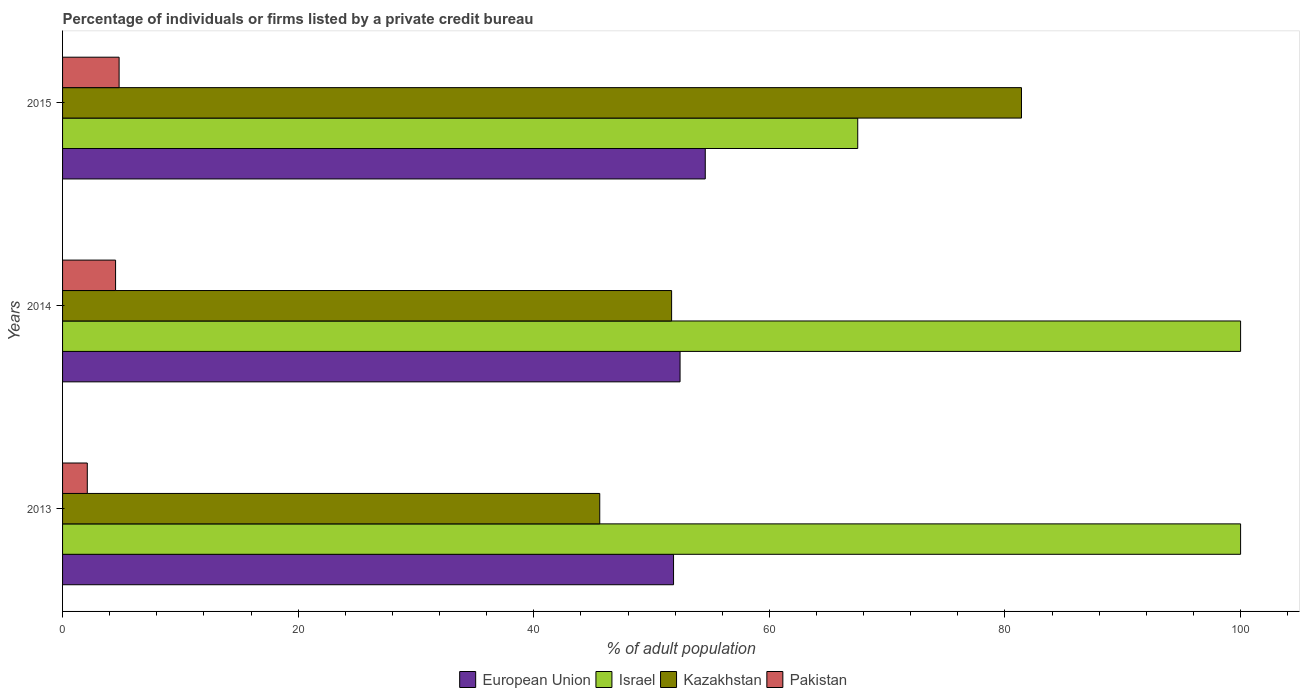How many bars are there on the 3rd tick from the bottom?
Keep it short and to the point. 4. In how many cases, is the number of bars for a given year not equal to the number of legend labels?
Provide a succinct answer. 0. What is the percentage of population listed by a private credit bureau in Israel in 2014?
Offer a terse response. 100. Across all years, what is the maximum percentage of population listed by a private credit bureau in Kazakhstan?
Make the answer very short. 81.4. Across all years, what is the minimum percentage of population listed by a private credit bureau in Israel?
Offer a very short reply. 67.5. What is the total percentage of population listed by a private credit bureau in Kazakhstan in the graph?
Provide a succinct answer. 178.7. What is the difference between the percentage of population listed by a private credit bureau in Kazakhstan in 2013 and that in 2014?
Offer a terse response. -6.1. What is the difference between the percentage of population listed by a private credit bureau in Pakistan in 2014 and the percentage of population listed by a private credit bureau in Israel in 2015?
Provide a short and direct response. -63. What is the average percentage of population listed by a private credit bureau in European Union per year?
Offer a terse response. 52.95. In the year 2013, what is the difference between the percentage of population listed by a private credit bureau in European Union and percentage of population listed by a private credit bureau in Israel?
Provide a succinct answer. -48.14. In how many years, is the percentage of population listed by a private credit bureau in Kazakhstan greater than 36 %?
Provide a short and direct response. 3. What is the ratio of the percentage of population listed by a private credit bureau in Kazakhstan in 2013 to that in 2014?
Your response must be concise. 0.88. Is the percentage of population listed by a private credit bureau in European Union in 2013 less than that in 2014?
Give a very brief answer. Yes. What is the difference between the highest and the second highest percentage of population listed by a private credit bureau in Kazakhstan?
Your response must be concise. 29.7. What is the difference between the highest and the lowest percentage of population listed by a private credit bureau in Kazakhstan?
Keep it short and to the point. 35.8. In how many years, is the percentage of population listed by a private credit bureau in Israel greater than the average percentage of population listed by a private credit bureau in Israel taken over all years?
Offer a very short reply. 2. Is the sum of the percentage of population listed by a private credit bureau in Kazakhstan in 2013 and 2014 greater than the maximum percentage of population listed by a private credit bureau in Pakistan across all years?
Ensure brevity in your answer.  Yes. Is it the case that in every year, the sum of the percentage of population listed by a private credit bureau in Pakistan and percentage of population listed by a private credit bureau in Kazakhstan is greater than the sum of percentage of population listed by a private credit bureau in Israel and percentage of population listed by a private credit bureau in European Union?
Offer a very short reply. No. What does the 4th bar from the top in 2015 represents?
Provide a short and direct response. European Union. What does the 3rd bar from the bottom in 2014 represents?
Offer a terse response. Kazakhstan. How many bars are there?
Offer a terse response. 12. How many years are there in the graph?
Ensure brevity in your answer.  3. What is the difference between two consecutive major ticks on the X-axis?
Your response must be concise. 20. Are the values on the major ticks of X-axis written in scientific E-notation?
Offer a very short reply. No. Does the graph contain any zero values?
Give a very brief answer. No. Does the graph contain grids?
Your answer should be compact. No. How many legend labels are there?
Ensure brevity in your answer.  4. What is the title of the graph?
Ensure brevity in your answer.  Percentage of individuals or firms listed by a private credit bureau. What is the label or title of the X-axis?
Provide a short and direct response. % of adult population. What is the % of adult population of European Union in 2013?
Provide a succinct answer. 51.86. What is the % of adult population of Israel in 2013?
Your answer should be compact. 100. What is the % of adult population in Kazakhstan in 2013?
Give a very brief answer. 45.6. What is the % of adult population in European Union in 2014?
Your answer should be compact. 52.42. What is the % of adult population of Israel in 2014?
Offer a very short reply. 100. What is the % of adult population in Kazakhstan in 2014?
Provide a short and direct response. 51.7. What is the % of adult population in Pakistan in 2014?
Offer a terse response. 4.5. What is the % of adult population in European Union in 2015?
Offer a very short reply. 54.56. What is the % of adult population of Israel in 2015?
Give a very brief answer. 67.5. What is the % of adult population of Kazakhstan in 2015?
Your response must be concise. 81.4. What is the % of adult population of Pakistan in 2015?
Your answer should be very brief. 4.8. Across all years, what is the maximum % of adult population of European Union?
Your answer should be compact. 54.56. Across all years, what is the maximum % of adult population of Kazakhstan?
Make the answer very short. 81.4. Across all years, what is the maximum % of adult population in Pakistan?
Your response must be concise. 4.8. Across all years, what is the minimum % of adult population of European Union?
Ensure brevity in your answer.  51.86. Across all years, what is the minimum % of adult population in Israel?
Ensure brevity in your answer.  67.5. Across all years, what is the minimum % of adult population in Kazakhstan?
Offer a very short reply. 45.6. Across all years, what is the minimum % of adult population of Pakistan?
Offer a terse response. 2.1. What is the total % of adult population of European Union in the graph?
Keep it short and to the point. 158.84. What is the total % of adult population of Israel in the graph?
Keep it short and to the point. 267.5. What is the total % of adult population of Kazakhstan in the graph?
Your response must be concise. 178.7. What is the difference between the % of adult population of European Union in 2013 and that in 2014?
Keep it short and to the point. -0.55. What is the difference between the % of adult population in Israel in 2013 and that in 2014?
Keep it short and to the point. 0. What is the difference between the % of adult population of Kazakhstan in 2013 and that in 2014?
Make the answer very short. -6.1. What is the difference between the % of adult population of Pakistan in 2013 and that in 2014?
Give a very brief answer. -2.4. What is the difference between the % of adult population of European Union in 2013 and that in 2015?
Provide a short and direct response. -2.69. What is the difference between the % of adult population in Israel in 2013 and that in 2015?
Your answer should be compact. 32.5. What is the difference between the % of adult population of Kazakhstan in 2013 and that in 2015?
Make the answer very short. -35.8. What is the difference between the % of adult population in European Union in 2014 and that in 2015?
Offer a very short reply. -2.14. What is the difference between the % of adult population in Israel in 2014 and that in 2015?
Your response must be concise. 32.5. What is the difference between the % of adult population of Kazakhstan in 2014 and that in 2015?
Provide a short and direct response. -29.7. What is the difference between the % of adult population of Pakistan in 2014 and that in 2015?
Offer a very short reply. -0.3. What is the difference between the % of adult population of European Union in 2013 and the % of adult population of Israel in 2014?
Ensure brevity in your answer.  -48.14. What is the difference between the % of adult population of European Union in 2013 and the % of adult population of Kazakhstan in 2014?
Provide a short and direct response. 0.16. What is the difference between the % of adult population in European Union in 2013 and the % of adult population in Pakistan in 2014?
Provide a short and direct response. 47.36. What is the difference between the % of adult population of Israel in 2013 and the % of adult population of Kazakhstan in 2014?
Your answer should be compact. 48.3. What is the difference between the % of adult population of Israel in 2013 and the % of adult population of Pakistan in 2014?
Your response must be concise. 95.5. What is the difference between the % of adult population in Kazakhstan in 2013 and the % of adult population in Pakistan in 2014?
Make the answer very short. 41.1. What is the difference between the % of adult population in European Union in 2013 and the % of adult population in Israel in 2015?
Ensure brevity in your answer.  -15.64. What is the difference between the % of adult population in European Union in 2013 and the % of adult population in Kazakhstan in 2015?
Keep it short and to the point. -29.54. What is the difference between the % of adult population in European Union in 2013 and the % of adult population in Pakistan in 2015?
Your answer should be very brief. 47.06. What is the difference between the % of adult population of Israel in 2013 and the % of adult population of Pakistan in 2015?
Provide a short and direct response. 95.2. What is the difference between the % of adult population of Kazakhstan in 2013 and the % of adult population of Pakistan in 2015?
Provide a short and direct response. 40.8. What is the difference between the % of adult population in European Union in 2014 and the % of adult population in Israel in 2015?
Your response must be concise. -15.08. What is the difference between the % of adult population of European Union in 2014 and the % of adult population of Kazakhstan in 2015?
Give a very brief answer. -28.98. What is the difference between the % of adult population in European Union in 2014 and the % of adult population in Pakistan in 2015?
Your answer should be very brief. 47.62. What is the difference between the % of adult population in Israel in 2014 and the % of adult population in Pakistan in 2015?
Your answer should be very brief. 95.2. What is the difference between the % of adult population of Kazakhstan in 2014 and the % of adult population of Pakistan in 2015?
Provide a succinct answer. 46.9. What is the average % of adult population in European Union per year?
Keep it short and to the point. 52.95. What is the average % of adult population of Israel per year?
Keep it short and to the point. 89.17. What is the average % of adult population in Kazakhstan per year?
Make the answer very short. 59.57. In the year 2013, what is the difference between the % of adult population in European Union and % of adult population in Israel?
Provide a succinct answer. -48.14. In the year 2013, what is the difference between the % of adult population in European Union and % of adult population in Kazakhstan?
Ensure brevity in your answer.  6.26. In the year 2013, what is the difference between the % of adult population in European Union and % of adult population in Pakistan?
Provide a short and direct response. 49.76. In the year 2013, what is the difference between the % of adult population of Israel and % of adult population of Kazakhstan?
Provide a succinct answer. 54.4. In the year 2013, what is the difference between the % of adult population of Israel and % of adult population of Pakistan?
Provide a short and direct response. 97.9. In the year 2013, what is the difference between the % of adult population of Kazakhstan and % of adult population of Pakistan?
Your answer should be very brief. 43.5. In the year 2014, what is the difference between the % of adult population of European Union and % of adult population of Israel?
Offer a terse response. -47.58. In the year 2014, what is the difference between the % of adult population in European Union and % of adult population in Kazakhstan?
Ensure brevity in your answer.  0.72. In the year 2014, what is the difference between the % of adult population in European Union and % of adult population in Pakistan?
Your response must be concise. 47.92. In the year 2014, what is the difference between the % of adult population in Israel and % of adult population in Kazakhstan?
Make the answer very short. 48.3. In the year 2014, what is the difference between the % of adult population of Israel and % of adult population of Pakistan?
Provide a succinct answer. 95.5. In the year 2014, what is the difference between the % of adult population of Kazakhstan and % of adult population of Pakistan?
Your answer should be very brief. 47.2. In the year 2015, what is the difference between the % of adult population in European Union and % of adult population in Israel?
Provide a succinct answer. -12.94. In the year 2015, what is the difference between the % of adult population in European Union and % of adult population in Kazakhstan?
Ensure brevity in your answer.  -26.84. In the year 2015, what is the difference between the % of adult population in European Union and % of adult population in Pakistan?
Offer a very short reply. 49.76. In the year 2015, what is the difference between the % of adult population of Israel and % of adult population of Kazakhstan?
Your response must be concise. -13.9. In the year 2015, what is the difference between the % of adult population in Israel and % of adult population in Pakistan?
Make the answer very short. 62.7. In the year 2015, what is the difference between the % of adult population of Kazakhstan and % of adult population of Pakistan?
Give a very brief answer. 76.6. What is the ratio of the % of adult population in European Union in 2013 to that in 2014?
Your response must be concise. 0.99. What is the ratio of the % of adult population in Kazakhstan in 2013 to that in 2014?
Provide a short and direct response. 0.88. What is the ratio of the % of adult population in Pakistan in 2013 to that in 2014?
Offer a terse response. 0.47. What is the ratio of the % of adult population in European Union in 2013 to that in 2015?
Provide a succinct answer. 0.95. What is the ratio of the % of adult population in Israel in 2013 to that in 2015?
Make the answer very short. 1.48. What is the ratio of the % of adult population of Kazakhstan in 2013 to that in 2015?
Make the answer very short. 0.56. What is the ratio of the % of adult population of Pakistan in 2013 to that in 2015?
Offer a very short reply. 0.44. What is the ratio of the % of adult population in European Union in 2014 to that in 2015?
Keep it short and to the point. 0.96. What is the ratio of the % of adult population in Israel in 2014 to that in 2015?
Give a very brief answer. 1.48. What is the ratio of the % of adult population in Kazakhstan in 2014 to that in 2015?
Provide a short and direct response. 0.64. What is the difference between the highest and the second highest % of adult population in European Union?
Your answer should be compact. 2.14. What is the difference between the highest and the second highest % of adult population in Kazakhstan?
Offer a terse response. 29.7. What is the difference between the highest and the lowest % of adult population of European Union?
Make the answer very short. 2.69. What is the difference between the highest and the lowest % of adult population in Israel?
Give a very brief answer. 32.5. What is the difference between the highest and the lowest % of adult population in Kazakhstan?
Keep it short and to the point. 35.8. 